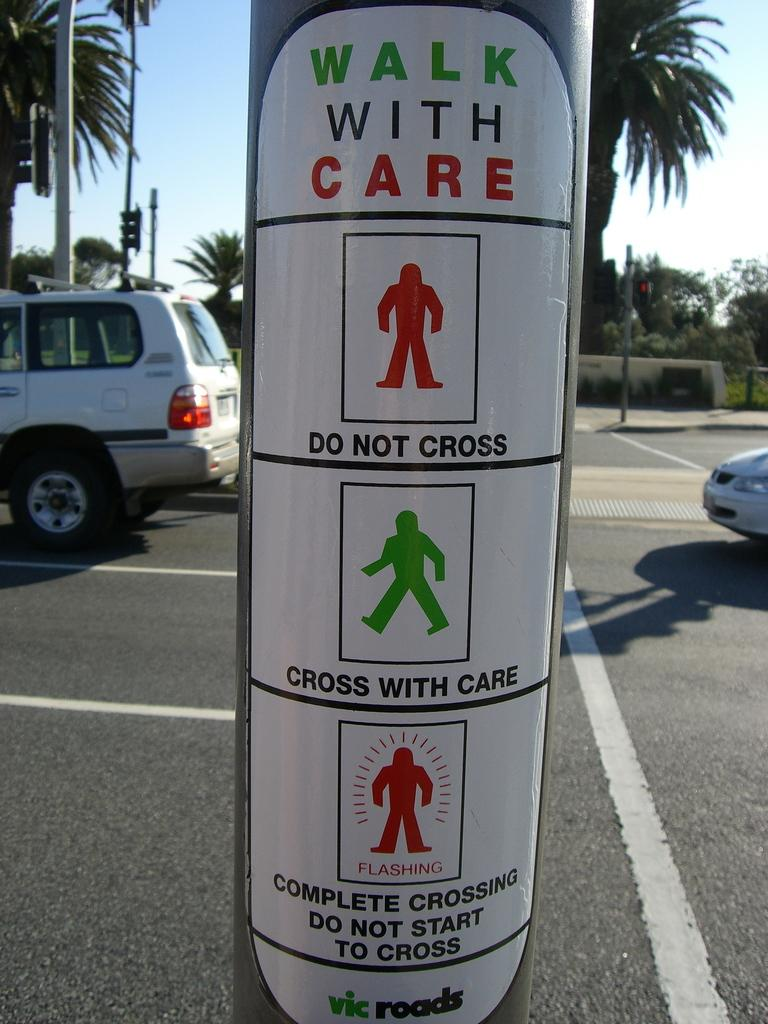What is attached to the pole in the image? There is a sticker on the pole in the image. What can be seen on the road in the image? There are cars on the road in the image. What other poles can be seen in the image? There are poles in the background of the image. What else is visible in the background of the image? There are traffic signals and trees in the background of the image. What is visible at the top of the image? The sky is visible at the top of the image. What type of animal is protesting on the pole in the image? There is no animal present in the image, and no protest is taking place. 